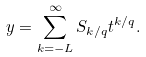Convert formula to latex. <formula><loc_0><loc_0><loc_500><loc_500>y = \sum _ { k = - L } ^ { \infty } S _ { k / q } t ^ { k / q } .</formula> 